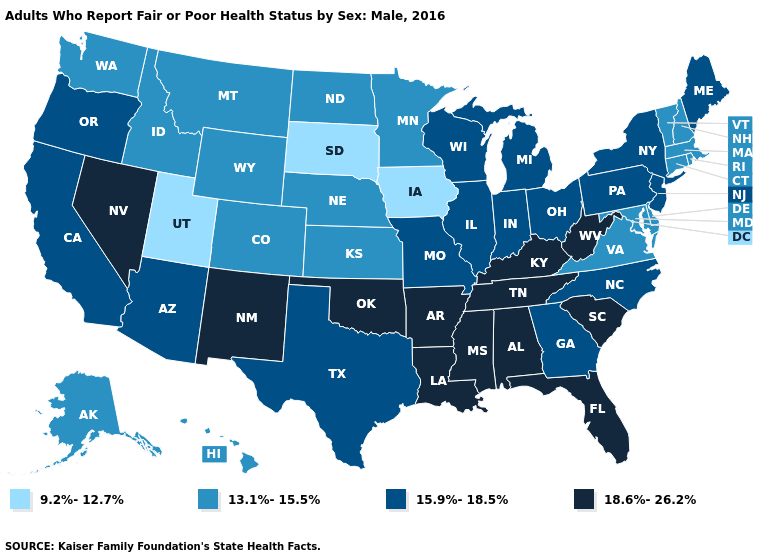What is the lowest value in the USA?
Quick response, please. 9.2%-12.7%. Name the states that have a value in the range 15.9%-18.5%?
Answer briefly. Arizona, California, Georgia, Illinois, Indiana, Maine, Michigan, Missouri, New Jersey, New York, North Carolina, Ohio, Oregon, Pennsylvania, Texas, Wisconsin. What is the lowest value in the USA?
Be succinct. 9.2%-12.7%. What is the lowest value in the USA?
Short answer required. 9.2%-12.7%. Name the states that have a value in the range 13.1%-15.5%?
Give a very brief answer. Alaska, Colorado, Connecticut, Delaware, Hawaii, Idaho, Kansas, Maryland, Massachusetts, Minnesota, Montana, Nebraska, New Hampshire, North Dakota, Rhode Island, Vermont, Virginia, Washington, Wyoming. Name the states that have a value in the range 13.1%-15.5%?
Write a very short answer. Alaska, Colorado, Connecticut, Delaware, Hawaii, Idaho, Kansas, Maryland, Massachusetts, Minnesota, Montana, Nebraska, New Hampshire, North Dakota, Rhode Island, Vermont, Virginia, Washington, Wyoming. What is the highest value in the South ?
Be succinct. 18.6%-26.2%. Among the states that border Tennessee , does Georgia have the highest value?
Keep it brief. No. Which states have the lowest value in the USA?
Write a very short answer. Iowa, South Dakota, Utah. What is the value of Kentucky?
Answer briefly. 18.6%-26.2%. Name the states that have a value in the range 9.2%-12.7%?
Answer briefly. Iowa, South Dakota, Utah. Is the legend a continuous bar?
Give a very brief answer. No. What is the value of Idaho?
Keep it brief. 13.1%-15.5%. Which states have the lowest value in the Northeast?
Be succinct. Connecticut, Massachusetts, New Hampshire, Rhode Island, Vermont. Does West Virginia have the same value as Louisiana?
Keep it brief. Yes. 